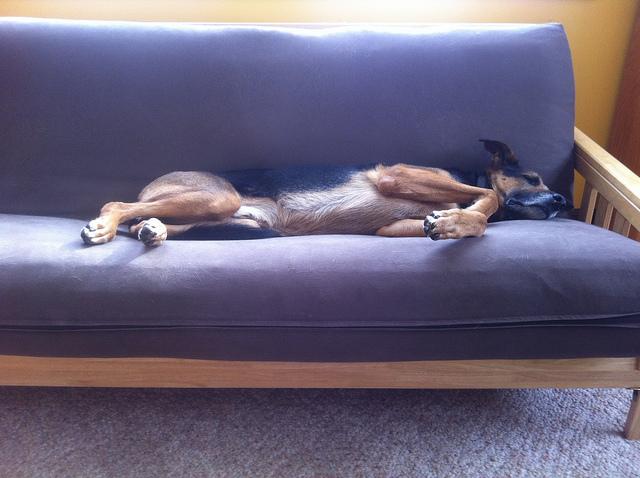What type of animal is this?
Quick response, please. Dog. Does the animal appear relaxed?
Answer briefly. Yes. What is the dominant breed of dog in this picture?
Give a very brief answer. German shepherd. 